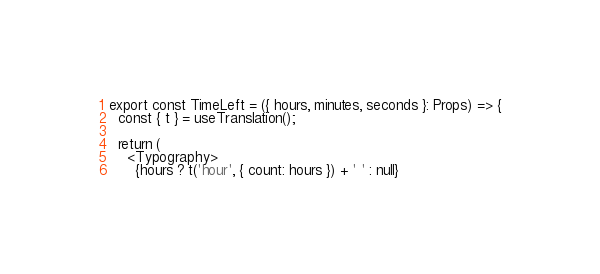<code> <loc_0><loc_0><loc_500><loc_500><_TypeScript_>export const TimeLeft = ({ hours, minutes, seconds }: Props) => {
  const { t } = useTranslation();

  return (
    <Typography>
      {hours ? t('hour', { count: hours }) + ' ' : null}</code> 